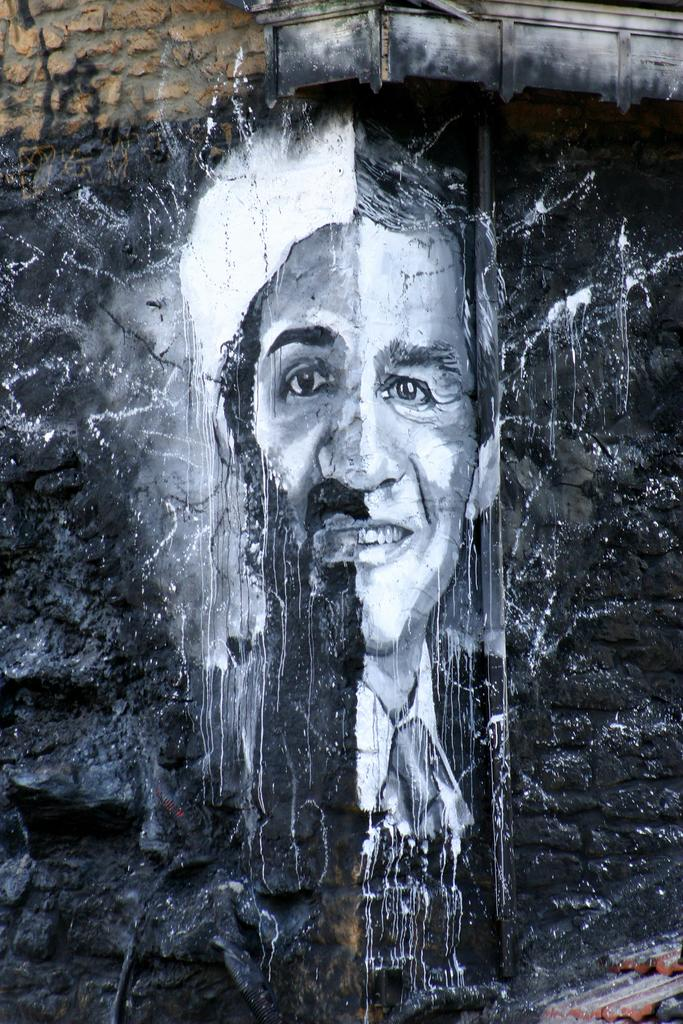What is depicted on the wall in the image? There is a painting of a person on the wall. Are there any additional elements attached to the wall? Yes, stones are attached to the wall in the top left. What is the color of the background in the painting? The background of the painting is black in color. Can you tell me how many curtains are hanging from the wall in the image? There are no curtains present in the image. What type of toothpaste is used by the person in the painting? The painting does not depict the person using toothpaste, so it cannot be determined from the image. 